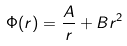Convert formula to latex. <formula><loc_0><loc_0><loc_500><loc_500>\Phi ( r ) = \frac { A } { r } + B r ^ { 2 }</formula> 